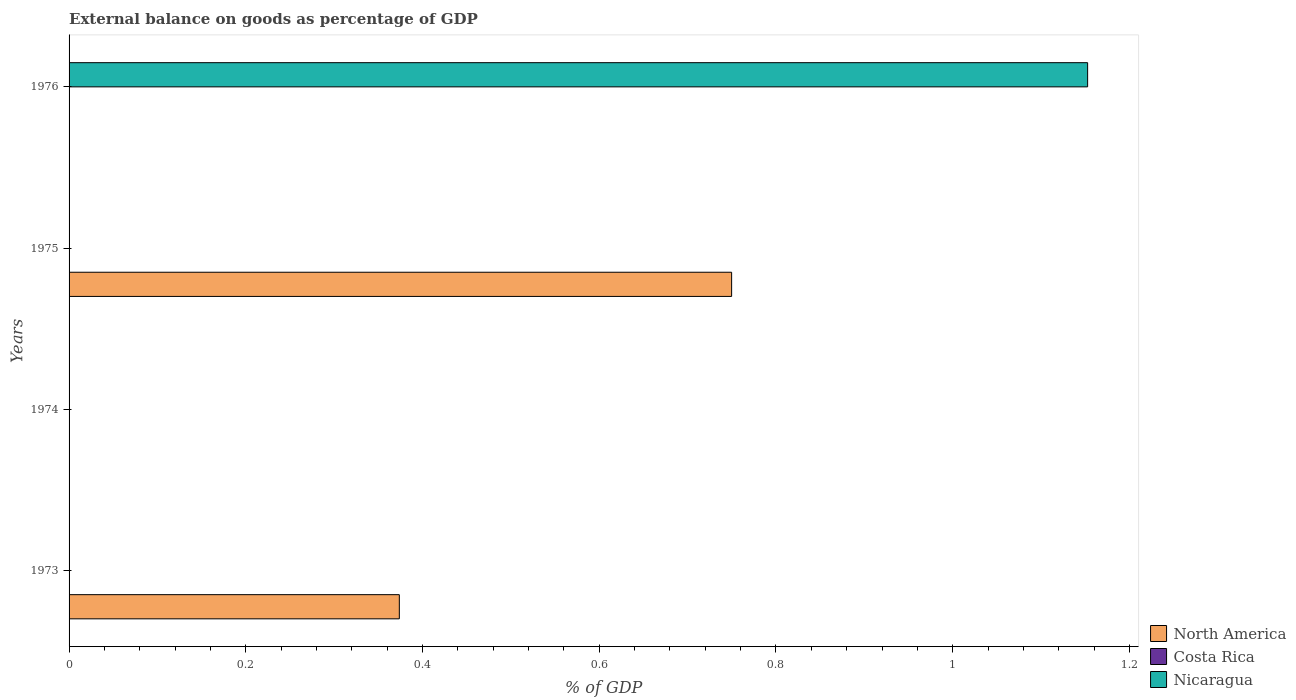How many different coloured bars are there?
Ensure brevity in your answer.  2. Are the number of bars on each tick of the Y-axis equal?
Give a very brief answer. No. How many bars are there on the 3rd tick from the top?
Your answer should be compact. 0. What is the label of the 2nd group of bars from the top?
Offer a terse response. 1975. Across all years, what is the maximum external balance on goods as percentage of GDP in North America?
Your response must be concise. 0.75. Across all years, what is the minimum external balance on goods as percentage of GDP in North America?
Provide a succinct answer. 0. In which year was the external balance on goods as percentage of GDP in North America maximum?
Provide a short and direct response. 1975. What is the total external balance on goods as percentage of GDP in North America in the graph?
Offer a very short reply. 1.12. What is the difference between the external balance on goods as percentage of GDP in North America in 1973 and that in 1975?
Ensure brevity in your answer.  -0.38. What is the average external balance on goods as percentage of GDP in Nicaragua per year?
Your answer should be very brief. 0.29. In how many years, is the external balance on goods as percentage of GDP in Nicaragua greater than 0.04 %?
Keep it short and to the point. 1. Is the external balance on goods as percentage of GDP in North America in 1973 less than that in 1975?
Your answer should be compact. Yes. What is the difference between the highest and the lowest external balance on goods as percentage of GDP in Nicaragua?
Your answer should be compact. 1.15. How many bars are there?
Your answer should be very brief. 3. What is the difference between two consecutive major ticks on the X-axis?
Your answer should be very brief. 0.2. Does the graph contain any zero values?
Your answer should be compact. Yes. How many legend labels are there?
Make the answer very short. 3. What is the title of the graph?
Offer a very short reply. External balance on goods as percentage of GDP. Does "Portugal" appear as one of the legend labels in the graph?
Your response must be concise. No. What is the label or title of the X-axis?
Provide a succinct answer. % of GDP. What is the % of GDP in North America in 1973?
Your answer should be compact. 0.37. What is the % of GDP of Costa Rica in 1973?
Your response must be concise. 0. What is the % of GDP of Nicaragua in 1974?
Give a very brief answer. 0. What is the % of GDP in North America in 1975?
Make the answer very short. 0.75. What is the % of GDP in Nicaragua in 1975?
Keep it short and to the point. 0. What is the % of GDP in North America in 1976?
Your answer should be very brief. 0. What is the % of GDP of Costa Rica in 1976?
Offer a terse response. 0. What is the % of GDP of Nicaragua in 1976?
Give a very brief answer. 1.15. Across all years, what is the maximum % of GDP of North America?
Give a very brief answer. 0.75. Across all years, what is the maximum % of GDP of Nicaragua?
Offer a terse response. 1.15. What is the total % of GDP in North America in the graph?
Your response must be concise. 1.12. What is the total % of GDP in Costa Rica in the graph?
Your answer should be very brief. 0. What is the total % of GDP of Nicaragua in the graph?
Offer a very short reply. 1.15. What is the difference between the % of GDP in North America in 1973 and that in 1975?
Offer a terse response. -0.38. What is the difference between the % of GDP in North America in 1973 and the % of GDP in Nicaragua in 1976?
Offer a terse response. -0.78. What is the difference between the % of GDP of North America in 1975 and the % of GDP of Nicaragua in 1976?
Give a very brief answer. -0.4. What is the average % of GDP of North America per year?
Provide a succinct answer. 0.28. What is the average % of GDP in Nicaragua per year?
Provide a succinct answer. 0.29. What is the ratio of the % of GDP in North America in 1973 to that in 1975?
Give a very brief answer. 0.5. What is the difference between the highest and the lowest % of GDP of North America?
Ensure brevity in your answer.  0.75. What is the difference between the highest and the lowest % of GDP in Nicaragua?
Give a very brief answer. 1.15. 